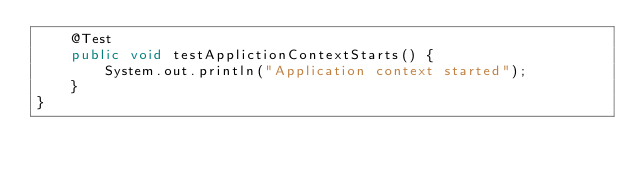<code> <loc_0><loc_0><loc_500><loc_500><_Java_>    @Test
    public void testApplictionContextStarts() {
        System.out.println("Application context started");
    }
}
</code> 